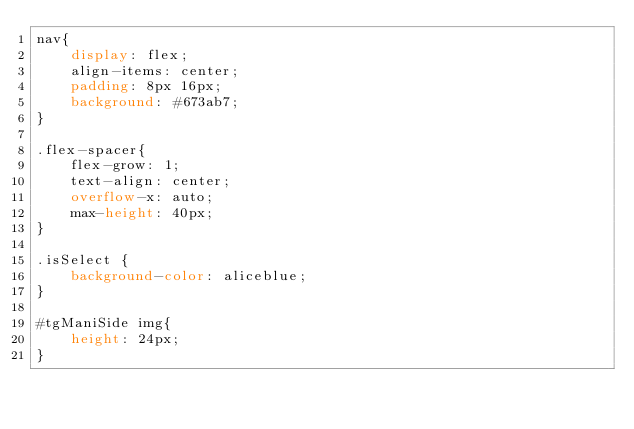Convert code to text. <code><loc_0><loc_0><loc_500><loc_500><_CSS_>nav{
    display: flex;
    align-items: center;
    padding: 8px 16px;
    background: #673ab7;
}

.flex-spacer{
    flex-grow: 1;
    text-align: center;
    overflow-x: auto;
    max-height: 40px;
}

.isSelect {
    background-color: aliceblue;
}

#tgManiSide img{
    height: 24px;
}</code> 